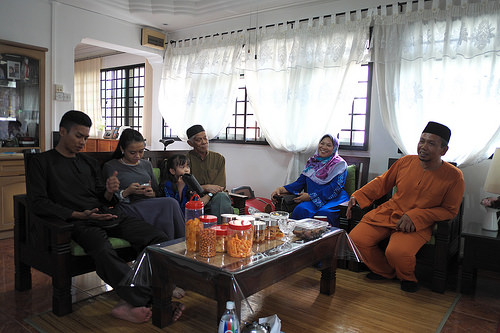<image>
Is the bottle on the table? No. The bottle is not positioned on the table. They may be near each other, but the bottle is not supported by or resting on top of the table. 